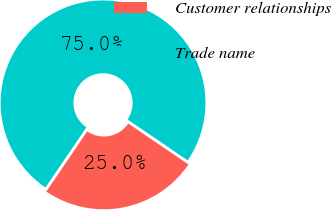<chart> <loc_0><loc_0><loc_500><loc_500><pie_chart><fcel>Customer relationships<fcel>Trade name<nl><fcel>25.0%<fcel>75.0%<nl></chart> 